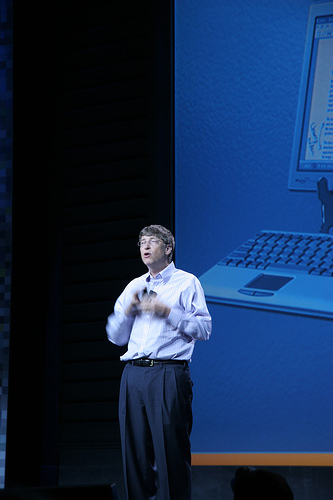<image>
Is the man under the projection? Yes. The man is positioned underneath the projection, with the projection above it in the vertical space. 